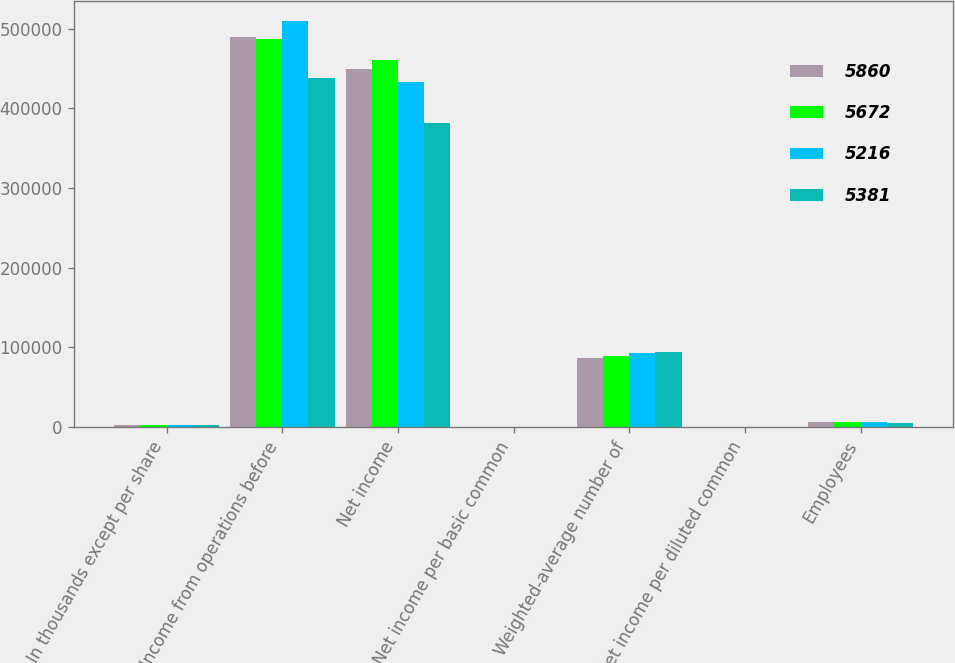Convert chart. <chart><loc_0><loc_0><loc_500><loc_500><stacked_bar_chart><ecel><fcel>In thousands except per share<fcel>Income from operations before<fcel>Net income<fcel>Net income per basic common<fcel>Weighted-average number of<fcel>Net income per diluted common<fcel>Employees<nl><fcel>5860<fcel>2013<fcel>490105<fcel>450003<fcel>5.27<fcel>86546<fcel>5.2<fcel>5965<nl><fcel>5672<fcel>2012<fcel>487625<fcel>461443<fcel>5.25<fcel>88979<fcel>5.19<fcel>5860<nl><fcel>5216<fcel>2011<fcel>509252<fcel>432968<fcel>4.77<fcel>92325<fcel>4.69<fcel>5672<nl><fcel>5381<fcel>2010<fcel>437863<fcel>381763<fcel>4.13<fcel>94057<fcel>4.06<fcel>5381<nl></chart> 